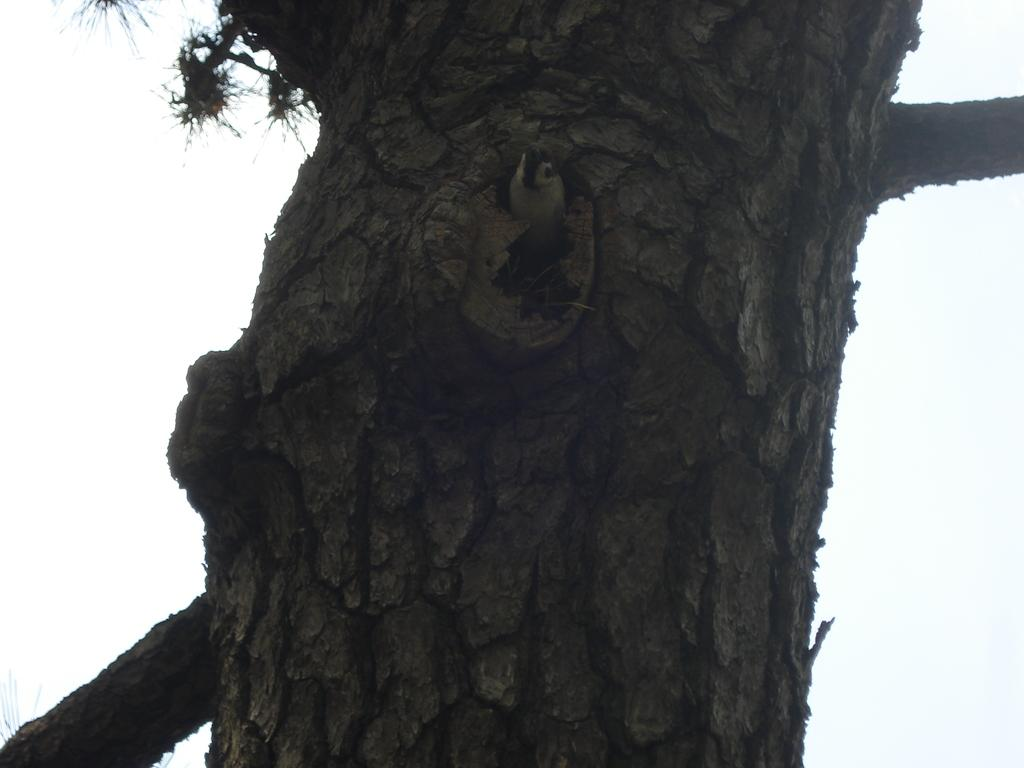What is the main object in the image? There is a tree trunk in the image. Is there any living creature on the tree trunk? Yes, a bird is present on the tree trunk in the image. What type of canvas is the bird using to paint its masterpiece in the image? There is no canvas or painting activity present in the image; it features a tree trunk with a bird on it. 